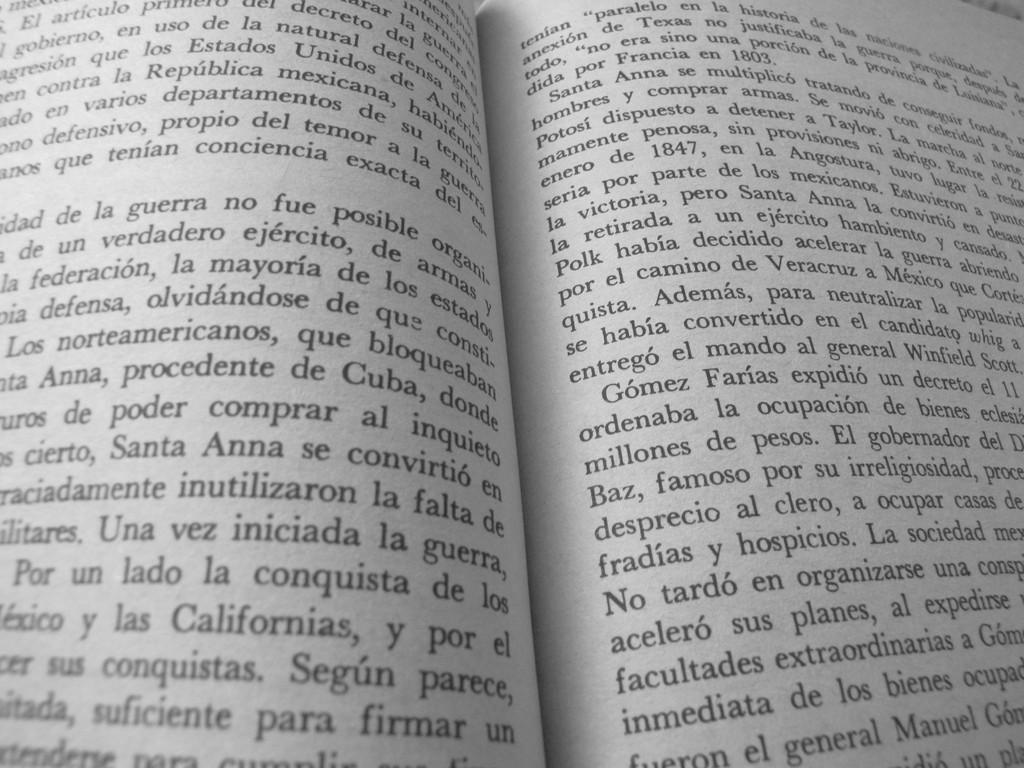<image>
Give a short and clear explanation of the subsequent image. A book is open and the year 1847 can be seen towards the top of the page on the right side. 